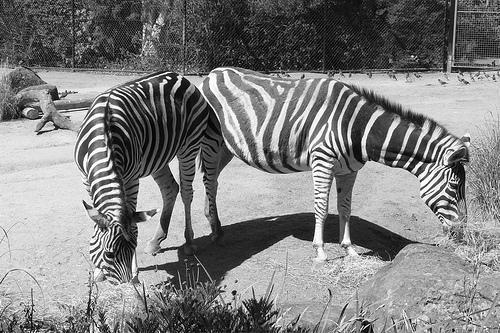How many zebras are there?
Give a very brief answer. 2. How many zebras are pictured?
Give a very brief answer. 2. How many zebras are there?
Give a very brief answer. 2. How many zebras are in the picture?
Give a very brief answer. 2. How many people have black shirts on?
Give a very brief answer. 0. 